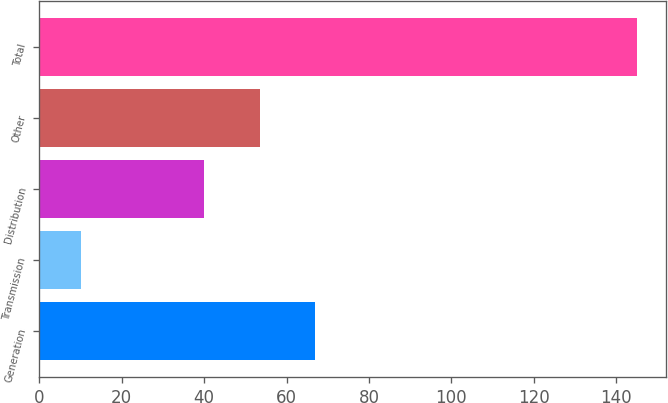Convert chart to OTSL. <chart><loc_0><loc_0><loc_500><loc_500><bar_chart><fcel>Generation<fcel>Transmission<fcel>Distribution<fcel>Other<fcel>Total<nl><fcel>67<fcel>10<fcel>40<fcel>53.5<fcel>145<nl></chart> 